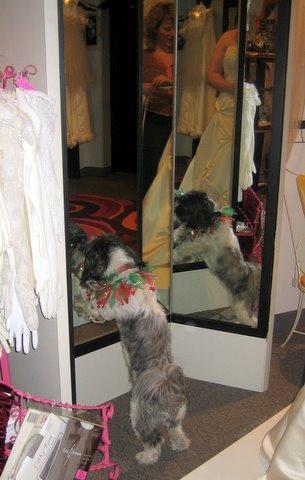How many people can you see?
Give a very brief answer. 2. How many dogs are in the picture?
Give a very brief answer. 2. How many white cars are on the road?
Give a very brief answer. 0. 